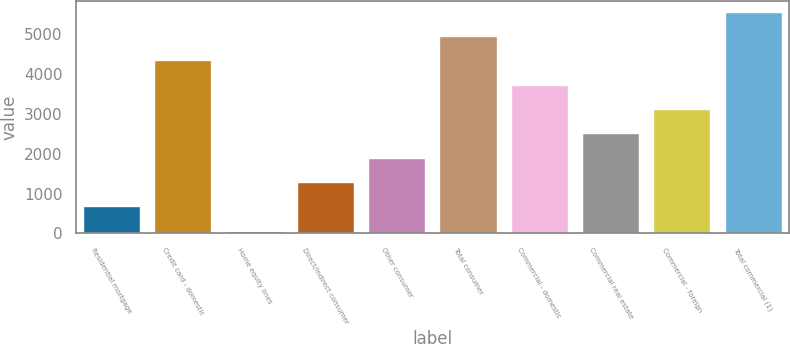Convert chart to OTSL. <chart><loc_0><loc_0><loc_500><loc_500><bar_chart><fcel>Residential mortgage<fcel>Credit card - domestic<fcel>Home equity lines<fcel>Direct/Indirect consumer<fcel>Other consumer<fcel>Total consumer<fcel>Commercial - domestic<fcel>Commercial real estate<fcel>Commercial - foreign<fcel>Total commercial (1)<nl><fcel>681.1<fcel>4335.7<fcel>72<fcel>1290.2<fcel>1899.3<fcel>4944.8<fcel>3726.6<fcel>2508.4<fcel>3117.5<fcel>5553.9<nl></chart> 